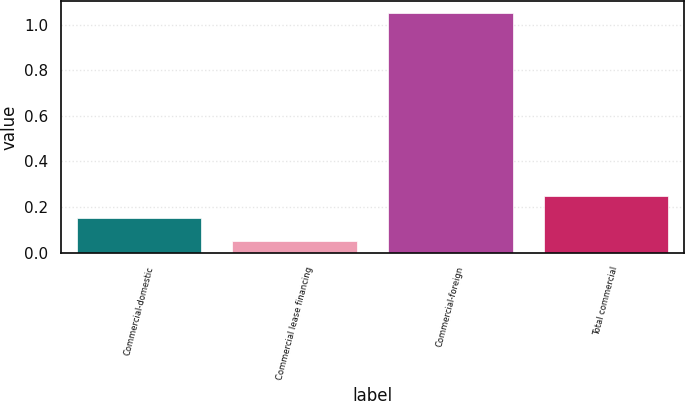Convert chart to OTSL. <chart><loc_0><loc_0><loc_500><loc_500><bar_chart><fcel>Commercial-domestic<fcel>Commercial lease financing<fcel>Commercial-foreign<fcel>Total commercial<nl><fcel>0.15<fcel>0.05<fcel>1.05<fcel>0.25<nl></chart> 